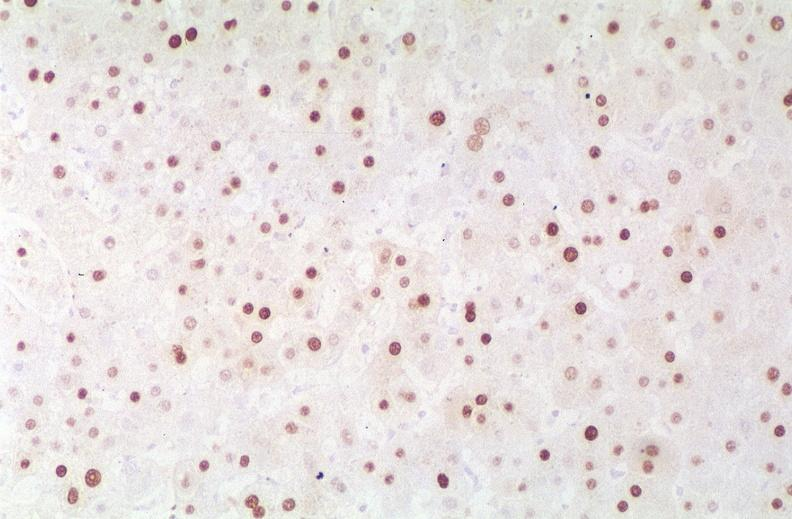does band constriction in skin above ankle of infant show hepatitis b virus, hbve antigen immunohistochemistry?
Answer the question using a single word or phrase. No 